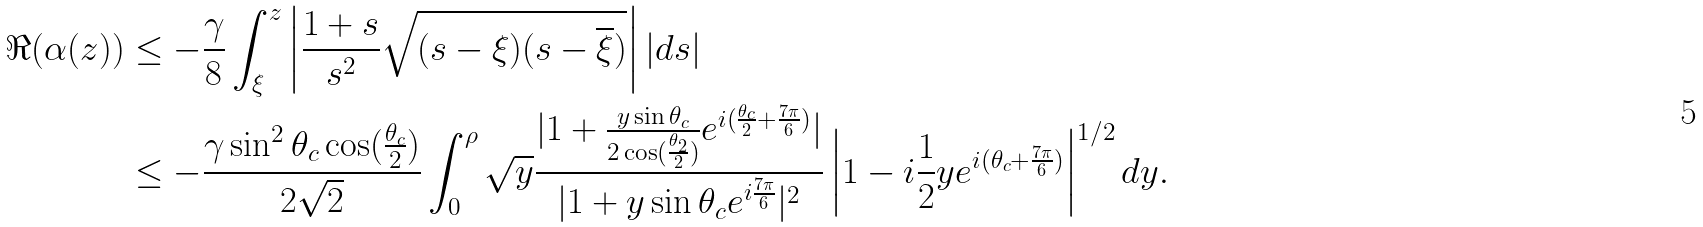<formula> <loc_0><loc_0><loc_500><loc_500>\Re ( \alpha ( z ) ) & \leq - \frac { \gamma } 8 \int _ { \xi } ^ { z } \left | \frac { 1 + s } { s ^ { 2 } } \sqrt { ( s - \xi ) ( s - \overline { \xi } ) } \right | | d s | \\ & \leq - \frac { \gamma \sin ^ { 2 } \theta _ { c } \cos ( \frac { \theta _ { c } } 2 ) } { 2 \sqrt { 2 } } \int _ { 0 } ^ { \rho } \sqrt { y } \frac { | 1 + \frac { y \sin \theta _ { c } } { 2 \cos ( \frac { \theta _ { 2 } } 2 ) } e ^ { i ( \frac { \theta _ { c } } 2 + \frac { 7 \pi } 6 ) } | } { | 1 + y \sin \theta _ { c } e ^ { i \frac { 7 \pi } 6 } | ^ { 2 } } \left | 1 - i \frac { 1 } { 2 } y e ^ { i ( \theta _ { c } + \frac { 7 \pi } 6 ) } \right | ^ { 1 / 2 } d y .</formula> 